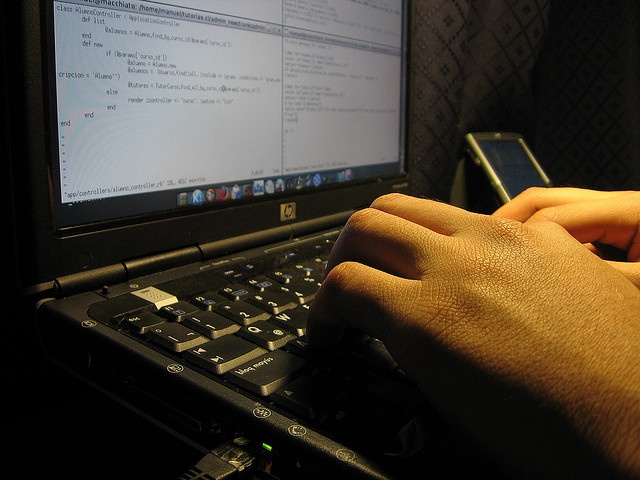Describe the objects in this image and their specific colors. I can see laptop in black, darkgray, gray, and olive tones, people in black, olive, maroon, and orange tones, keyboard in black, olive, and tan tones, and cell phone in black, olive, and tan tones in this image. 